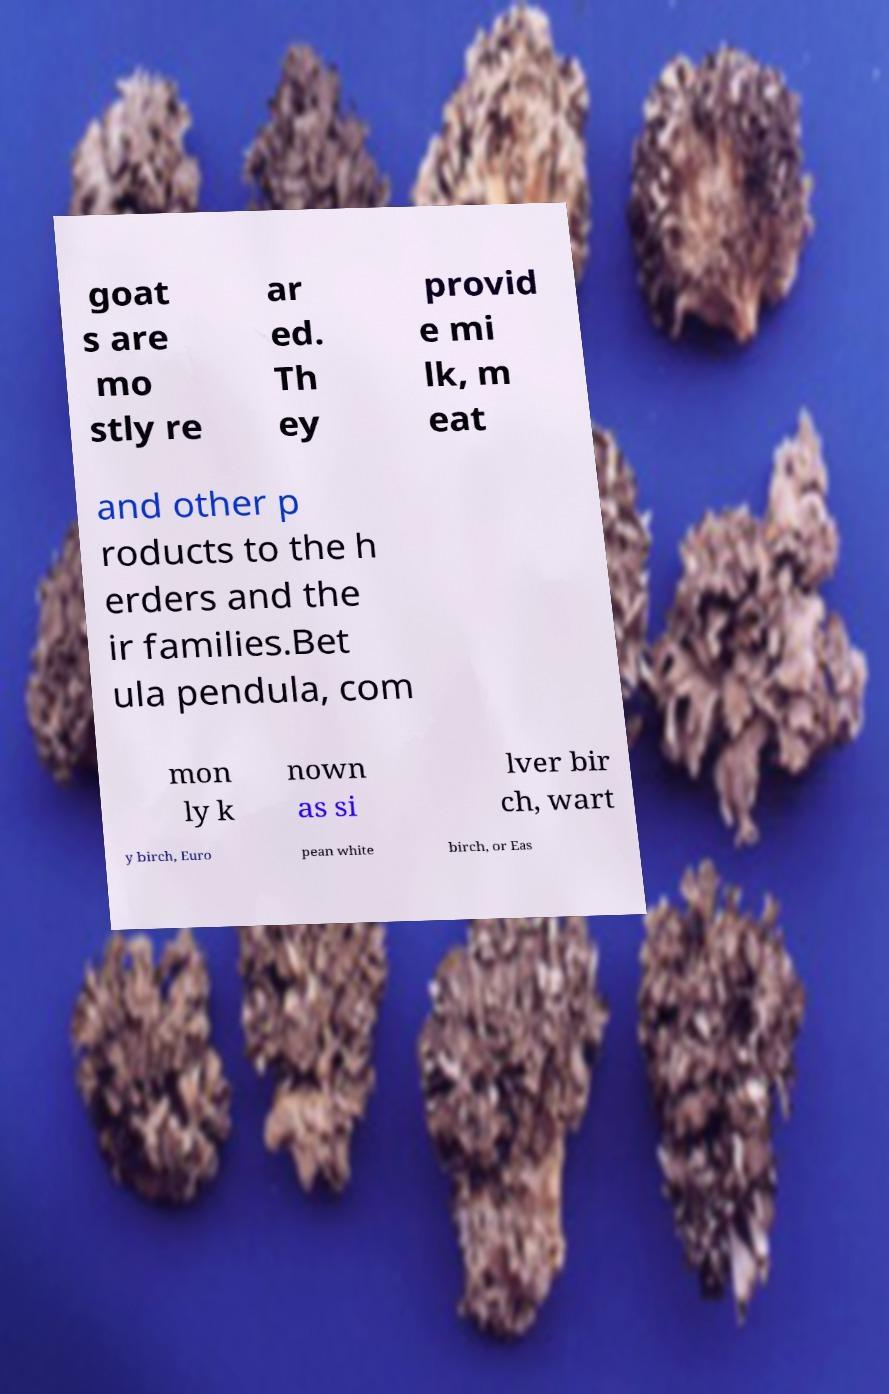Please read and relay the text visible in this image. What does it say? goat s are mo stly re ar ed. Th ey provid e mi lk, m eat and other p roducts to the h erders and the ir families.Bet ula pendula, com mon ly k nown as si lver bir ch, wart y birch, Euro pean white birch, or Eas 